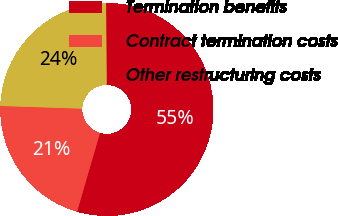Convert chart. <chart><loc_0><loc_0><loc_500><loc_500><pie_chart><fcel>Termination benefits<fcel>Contract termination costs<fcel>Other restructuring costs<nl><fcel>54.62%<fcel>21.01%<fcel>24.37%<nl></chart> 